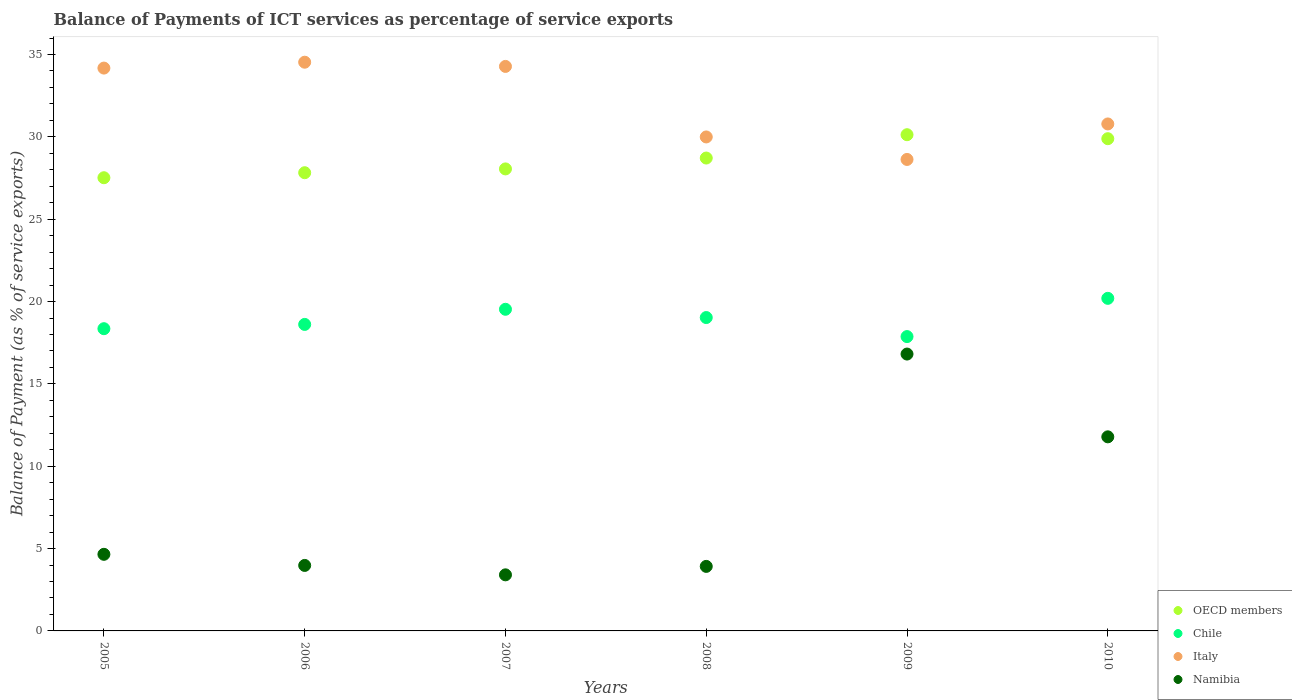How many different coloured dotlines are there?
Provide a succinct answer. 4. Is the number of dotlines equal to the number of legend labels?
Provide a short and direct response. Yes. What is the balance of payments of ICT services in Italy in 2010?
Your answer should be very brief. 30.78. Across all years, what is the maximum balance of payments of ICT services in OECD members?
Offer a terse response. 30.13. Across all years, what is the minimum balance of payments of ICT services in Namibia?
Ensure brevity in your answer.  3.41. What is the total balance of payments of ICT services in Namibia in the graph?
Keep it short and to the point. 44.55. What is the difference between the balance of payments of ICT services in Chile in 2006 and that in 2009?
Your answer should be compact. 0.74. What is the difference between the balance of payments of ICT services in OECD members in 2008 and the balance of payments of ICT services in Namibia in 2010?
Ensure brevity in your answer.  16.93. What is the average balance of payments of ICT services in Italy per year?
Ensure brevity in your answer.  32.06. In the year 2009, what is the difference between the balance of payments of ICT services in Italy and balance of payments of ICT services in Namibia?
Offer a very short reply. 11.82. What is the ratio of the balance of payments of ICT services in OECD members in 2008 to that in 2010?
Keep it short and to the point. 0.96. What is the difference between the highest and the second highest balance of payments of ICT services in Italy?
Provide a succinct answer. 0.26. What is the difference between the highest and the lowest balance of payments of ICT services in Italy?
Your response must be concise. 5.9. Is the sum of the balance of payments of ICT services in OECD members in 2007 and 2009 greater than the maximum balance of payments of ICT services in Italy across all years?
Ensure brevity in your answer.  Yes. Is it the case that in every year, the sum of the balance of payments of ICT services in Chile and balance of payments of ICT services in Italy  is greater than the sum of balance of payments of ICT services in Namibia and balance of payments of ICT services in OECD members?
Offer a very short reply. Yes. Is it the case that in every year, the sum of the balance of payments of ICT services in OECD members and balance of payments of ICT services in Italy  is greater than the balance of payments of ICT services in Namibia?
Offer a very short reply. Yes. Does the balance of payments of ICT services in Italy monotonically increase over the years?
Ensure brevity in your answer.  No. Is the balance of payments of ICT services in OECD members strictly greater than the balance of payments of ICT services in Chile over the years?
Your answer should be very brief. Yes. How many dotlines are there?
Keep it short and to the point. 4. How many years are there in the graph?
Ensure brevity in your answer.  6. Are the values on the major ticks of Y-axis written in scientific E-notation?
Provide a short and direct response. No. Does the graph contain grids?
Give a very brief answer. No. How many legend labels are there?
Give a very brief answer. 4. How are the legend labels stacked?
Your answer should be compact. Vertical. What is the title of the graph?
Ensure brevity in your answer.  Balance of Payments of ICT services as percentage of service exports. Does "Congo (Republic)" appear as one of the legend labels in the graph?
Provide a short and direct response. No. What is the label or title of the X-axis?
Your response must be concise. Years. What is the label or title of the Y-axis?
Provide a short and direct response. Balance of Payment (as % of service exports). What is the Balance of Payment (as % of service exports) in OECD members in 2005?
Provide a succinct answer. 27.52. What is the Balance of Payment (as % of service exports) in Chile in 2005?
Provide a succinct answer. 18.35. What is the Balance of Payment (as % of service exports) of Italy in 2005?
Provide a succinct answer. 34.17. What is the Balance of Payment (as % of service exports) of Namibia in 2005?
Make the answer very short. 4.65. What is the Balance of Payment (as % of service exports) of OECD members in 2006?
Give a very brief answer. 27.82. What is the Balance of Payment (as % of service exports) of Chile in 2006?
Your response must be concise. 18.61. What is the Balance of Payment (as % of service exports) in Italy in 2006?
Provide a short and direct response. 34.53. What is the Balance of Payment (as % of service exports) of Namibia in 2006?
Ensure brevity in your answer.  3.98. What is the Balance of Payment (as % of service exports) of OECD members in 2007?
Give a very brief answer. 28.05. What is the Balance of Payment (as % of service exports) of Chile in 2007?
Offer a terse response. 19.53. What is the Balance of Payment (as % of service exports) in Italy in 2007?
Keep it short and to the point. 34.28. What is the Balance of Payment (as % of service exports) of Namibia in 2007?
Ensure brevity in your answer.  3.41. What is the Balance of Payment (as % of service exports) in OECD members in 2008?
Give a very brief answer. 28.71. What is the Balance of Payment (as % of service exports) of Chile in 2008?
Offer a terse response. 19.03. What is the Balance of Payment (as % of service exports) in Italy in 2008?
Your response must be concise. 29.99. What is the Balance of Payment (as % of service exports) in Namibia in 2008?
Provide a short and direct response. 3.92. What is the Balance of Payment (as % of service exports) of OECD members in 2009?
Provide a short and direct response. 30.13. What is the Balance of Payment (as % of service exports) of Chile in 2009?
Your answer should be very brief. 17.87. What is the Balance of Payment (as % of service exports) of Italy in 2009?
Offer a very short reply. 28.63. What is the Balance of Payment (as % of service exports) in Namibia in 2009?
Provide a short and direct response. 16.81. What is the Balance of Payment (as % of service exports) of OECD members in 2010?
Provide a short and direct response. 29.89. What is the Balance of Payment (as % of service exports) in Chile in 2010?
Provide a succinct answer. 20.19. What is the Balance of Payment (as % of service exports) in Italy in 2010?
Offer a terse response. 30.78. What is the Balance of Payment (as % of service exports) of Namibia in 2010?
Your answer should be very brief. 11.78. Across all years, what is the maximum Balance of Payment (as % of service exports) of OECD members?
Make the answer very short. 30.13. Across all years, what is the maximum Balance of Payment (as % of service exports) of Chile?
Offer a very short reply. 20.19. Across all years, what is the maximum Balance of Payment (as % of service exports) in Italy?
Your response must be concise. 34.53. Across all years, what is the maximum Balance of Payment (as % of service exports) of Namibia?
Provide a succinct answer. 16.81. Across all years, what is the minimum Balance of Payment (as % of service exports) of OECD members?
Your response must be concise. 27.52. Across all years, what is the minimum Balance of Payment (as % of service exports) of Chile?
Offer a very short reply. 17.87. Across all years, what is the minimum Balance of Payment (as % of service exports) of Italy?
Your answer should be very brief. 28.63. Across all years, what is the minimum Balance of Payment (as % of service exports) in Namibia?
Keep it short and to the point. 3.41. What is the total Balance of Payment (as % of service exports) in OECD members in the graph?
Give a very brief answer. 172.12. What is the total Balance of Payment (as % of service exports) in Chile in the graph?
Offer a very short reply. 113.58. What is the total Balance of Payment (as % of service exports) in Italy in the graph?
Provide a succinct answer. 192.38. What is the total Balance of Payment (as % of service exports) in Namibia in the graph?
Your answer should be compact. 44.55. What is the difference between the Balance of Payment (as % of service exports) in OECD members in 2005 and that in 2006?
Provide a succinct answer. -0.3. What is the difference between the Balance of Payment (as % of service exports) of Chile in 2005 and that in 2006?
Offer a very short reply. -0.26. What is the difference between the Balance of Payment (as % of service exports) of Italy in 2005 and that in 2006?
Keep it short and to the point. -0.36. What is the difference between the Balance of Payment (as % of service exports) of Namibia in 2005 and that in 2006?
Make the answer very short. 0.67. What is the difference between the Balance of Payment (as % of service exports) in OECD members in 2005 and that in 2007?
Make the answer very short. -0.54. What is the difference between the Balance of Payment (as % of service exports) in Chile in 2005 and that in 2007?
Provide a short and direct response. -1.18. What is the difference between the Balance of Payment (as % of service exports) in Italy in 2005 and that in 2007?
Your answer should be compact. -0.1. What is the difference between the Balance of Payment (as % of service exports) in Namibia in 2005 and that in 2007?
Your answer should be compact. 1.25. What is the difference between the Balance of Payment (as % of service exports) of OECD members in 2005 and that in 2008?
Offer a very short reply. -1.2. What is the difference between the Balance of Payment (as % of service exports) of Chile in 2005 and that in 2008?
Provide a succinct answer. -0.68. What is the difference between the Balance of Payment (as % of service exports) of Italy in 2005 and that in 2008?
Your answer should be very brief. 4.18. What is the difference between the Balance of Payment (as % of service exports) of Namibia in 2005 and that in 2008?
Ensure brevity in your answer.  0.73. What is the difference between the Balance of Payment (as % of service exports) in OECD members in 2005 and that in 2009?
Offer a terse response. -2.61. What is the difference between the Balance of Payment (as % of service exports) in Chile in 2005 and that in 2009?
Make the answer very short. 0.48. What is the difference between the Balance of Payment (as % of service exports) of Italy in 2005 and that in 2009?
Offer a very short reply. 5.55. What is the difference between the Balance of Payment (as % of service exports) in Namibia in 2005 and that in 2009?
Provide a short and direct response. -12.16. What is the difference between the Balance of Payment (as % of service exports) of OECD members in 2005 and that in 2010?
Your answer should be very brief. -2.37. What is the difference between the Balance of Payment (as % of service exports) of Chile in 2005 and that in 2010?
Provide a succinct answer. -1.84. What is the difference between the Balance of Payment (as % of service exports) in Italy in 2005 and that in 2010?
Make the answer very short. 3.39. What is the difference between the Balance of Payment (as % of service exports) of Namibia in 2005 and that in 2010?
Make the answer very short. -7.13. What is the difference between the Balance of Payment (as % of service exports) in OECD members in 2006 and that in 2007?
Keep it short and to the point. -0.23. What is the difference between the Balance of Payment (as % of service exports) of Chile in 2006 and that in 2007?
Your response must be concise. -0.92. What is the difference between the Balance of Payment (as % of service exports) in Italy in 2006 and that in 2007?
Your answer should be compact. 0.26. What is the difference between the Balance of Payment (as % of service exports) of Namibia in 2006 and that in 2007?
Keep it short and to the point. 0.57. What is the difference between the Balance of Payment (as % of service exports) of OECD members in 2006 and that in 2008?
Give a very brief answer. -0.89. What is the difference between the Balance of Payment (as % of service exports) in Chile in 2006 and that in 2008?
Provide a short and direct response. -0.42. What is the difference between the Balance of Payment (as % of service exports) in Italy in 2006 and that in 2008?
Offer a very short reply. 4.54. What is the difference between the Balance of Payment (as % of service exports) in Namibia in 2006 and that in 2008?
Keep it short and to the point. 0.06. What is the difference between the Balance of Payment (as % of service exports) of OECD members in 2006 and that in 2009?
Provide a short and direct response. -2.31. What is the difference between the Balance of Payment (as % of service exports) of Chile in 2006 and that in 2009?
Provide a short and direct response. 0.74. What is the difference between the Balance of Payment (as % of service exports) of Italy in 2006 and that in 2009?
Provide a short and direct response. 5.9. What is the difference between the Balance of Payment (as % of service exports) in Namibia in 2006 and that in 2009?
Ensure brevity in your answer.  -12.83. What is the difference between the Balance of Payment (as % of service exports) in OECD members in 2006 and that in 2010?
Your response must be concise. -2.07. What is the difference between the Balance of Payment (as % of service exports) in Chile in 2006 and that in 2010?
Provide a short and direct response. -1.58. What is the difference between the Balance of Payment (as % of service exports) of Italy in 2006 and that in 2010?
Keep it short and to the point. 3.75. What is the difference between the Balance of Payment (as % of service exports) of Namibia in 2006 and that in 2010?
Offer a terse response. -7.81. What is the difference between the Balance of Payment (as % of service exports) of OECD members in 2007 and that in 2008?
Keep it short and to the point. -0.66. What is the difference between the Balance of Payment (as % of service exports) of Chile in 2007 and that in 2008?
Provide a succinct answer. 0.5. What is the difference between the Balance of Payment (as % of service exports) in Italy in 2007 and that in 2008?
Provide a succinct answer. 4.28. What is the difference between the Balance of Payment (as % of service exports) in Namibia in 2007 and that in 2008?
Keep it short and to the point. -0.51. What is the difference between the Balance of Payment (as % of service exports) in OECD members in 2007 and that in 2009?
Your response must be concise. -2.08. What is the difference between the Balance of Payment (as % of service exports) in Chile in 2007 and that in 2009?
Give a very brief answer. 1.66. What is the difference between the Balance of Payment (as % of service exports) in Italy in 2007 and that in 2009?
Your answer should be very brief. 5.65. What is the difference between the Balance of Payment (as % of service exports) of Namibia in 2007 and that in 2009?
Your response must be concise. -13.41. What is the difference between the Balance of Payment (as % of service exports) of OECD members in 2007 and that in 2010?
Make the answer very short. -1.83. What is the difference between the Balance of Payment (as % of service exports) in Chile in 2007 and that in 2010?
Provide a short and direct response. -0.66. What is the difference between the Balance of Payment (as % of service exports) in Italy in 2007 and that in 2010?
Give a very brief answer. 3.49. What is the difference between the Balance of Payment (as % of service exports) of Namibia in 2007 and that in 2010?
Your response must be concise. -8.38. What is the difference between the Balance of Payment (as % of service exports) in OECD members in 2008 and that in 2009?
Your answer should be compact. -1.42. What is the difference between the Balance of Payment (as % of service exports) in Chile in 2008 and that in 2009?
Your answer should be very brief. 1.16. What is the difference between the Balance of Payment (as % of service exports) in Italy in 2008 and that in 2009?
Offer a terse response. 1.37. What is the difference between the Balance of Payment (as % of service exports) in Namibia in 2008 and that in 2009?
Provide a succinct answer. -12.89. What is the difference between the Balance of Payment (as % of service exports) in OECD members in 2008 and that in 2010?
Provide a succinct answer. -1.17. What is the difference between the Balance of Payment (as % of service exports) of Chile in 2008 and that in 2010?
Provide a short and direct response. -1.17. What is the difference between the Balance of Payment (as % of service exports) in Italy in 2008 and that in 2010?
Offer a terse response. -0.79. What is the difference between the Balance of Payment (as % of service exports) of Namibia in 2008 and that in 2010?
Provide a short and direct response. -7.87. What is the difference between the Balance of Payment (as % of service exports) in OECD members in 2009 and that in 2010?
Offer a very short reply. 0.24. What is the difference between the Balance of Payment (as % of service exports) of Chile in 2009 and that in 2010?
Provide a succinct answer. -2.32. What is the difference between the Balance of Payment (as % of service exports) in Italy in 2009 and that in 2010?
Your response must be concise. -2.16. What is the difference between the Balance of Payment (as % of service exports) in Namibia in 2009 and that in 2010?
Offer a very short reply. 5.03. What is the difference between the Balance of Payment (as % of service exports) in OECD members in 2005 and the Balance of Payment (as % of service exports) in Chile in 2006?
Make the answer very short. 8.91. What is the difference between the Balance of Payment (as % of service exports) of OECD members in 2005 and the Balance of Payment (as % of service exports) of Italy in 2006?
Ensure brevity in your answer.  -7.01. What is the difference between the Balance of Payment (as % of service exports) in OECD members in 2005 and the Balance of Payment (as % of service exports) in Namibia in 2006?
Keep it short and to the point. 23.54. What is the difference between the Balance of Payment (as % of service exports) of Chile in 2005 and the Balance of Payment (as % of service exports) of Italy in 2006?
Make the answer very short. -16.18. What is the difference between the Balance of Payment (as % of service exports) of Chile in 2005 and the Balance of Payment (as % of service exports) of Namibia in 2006?
Make the answer very short. 14.37. What is the difference between the Balance of Payment (as % of service exports) in Italy in 2005 and the Balance of Payment (as % of service exports) in Namibia in 2006?
Offer a terse response. 30.2. What is the difference between the Balance of Payment (as % of service exports) in OECD members in 2005 and the Balance of Payment (as % of service exports) in Chile in 2007?
Your answer should be very brief. 7.99. What is the difference between the Balance of Payment (as % of service exports) in OECD members in 2005 and the Balance of Payment (as % of service exports) in Italy in 2007?
Your response must be concise. -6.76. What is the difference between the Balance of Payment (as % of service exports) in OECD members in 2005 and the Balance of Payment (as % of service exports) in Namibia in 2007?
Provide a succinct answer. 24.11. What is the difference between the Balance of Payment (as % of service exports) of Chile in 2005 and the Balance of Payment (as % of service exports) of Italy in 2007?
Your answer should be very brief. -15.92. What is the difference between the Balance of Payment (as % of service exports) of Chile in 2005 and the Balance of Payment (as % of service exports) of Namibia in 2007?
Keep it short and to the point. 14.95. What is the difference between the Balance of Payment (as % of service exports) of Italy in 2005 and the Balance of Payment (as % of service exports) of Namibia in 2007?
Make the answer very short. 30.77. What is the difference between the Balance of Payment (as % of service exports) of OECD members in 2005 and the Balance of Payment (as % of service exports) of Chile in 2008?
Give a very brief answer. 8.49. What is the difference between the Balance of Payment (as % of service exports) in OECD members in 2005 and the Balance of Payment (as % of service exports) in Italy in 2008?
Ensure brevity in your answer.  -2.48. What is the difference between the Balance of Payment (as % of service exports) in OECD members in 2005 and the Balance of Payment (as % of service exports) in Namibia in 2008?
Give a very brief answer. 23.6. What is the difference between the Balance of Payment (as % of service exports) of Chile in 2005 and the Balance of Payment (as % of service exports) of Italy in 2008?
Provide a succinct answer. -11.64. What is the difference between the Balance of Payment (as % of service exports) of Chile in 2005 and the Balance of Payment (as % of service exports) of Namibia in 2008?
Provide a succinct answer. 14.43. What is the difference between the Balance of Payment (as % of service exports) of Italy in 2005 and the Balance of Payment (as % of service exports) of Namibia in 2008?
Your answer should be compact. 30.26. What is the difference between the Balance of Payment (as % of service exports) of OECD members in 2005 and the Balance of Payment (as % of service exports) of Chile in 2009?
Give a very brief answer. 9.65. What is the difference between the Balance of Payment (as % of service exports) of OECD members in 2005 and the Balance of Payment (as % of service exports) of Italy in 2009?
Provide a short and direct response. -1.11. What is the difference between the Balance of Payment (as % of service exports) of OECD members in 2005 and the Balance of Payment (as % of service exports) of Namibia in 2009?
Your answer should be compact. 10.71. What is the difference between the Balance of Payment (as % of service exports) of Chile in 2005 and the Balance of Payment (as % of service exports) of Italy in 2009?
Offer a terse response. -10.28. What is the difference between the Balance of Payment (as % of service exports) of Chile in 2005 and the Balance of Payment (as % of service exports) of Namibia in 2009?
Give a very brief answer. 1.54. What is the difference between the Balance of Payment (as % of service exports) of Italy in 2005 and the Balance of Payment (as % of service exports) of Namibia in 2009?
Make the answer very short. 17.36. What is the difference between the Balance of Payment (as % of service exports) in OECD members in 2005 and the Balance of Payment (as % of service exports) in Chile in 2010?
Make the answer very short. 7.32. What is the difference between the Balance of Payment (as % of service exports) in OECD members in 2005 and the Balance of Payment (as % of service exports) in Italy in 2010?
Your answer should be compact. -3.27. What is the difference between the Balance of Payment (as % of service exports) of OECD members in 2005 and the Balance of Payment (as % of service exports) of Namibia in 2010?
Give a very brief answer. 15.73. What is the difference between the Balance of Payment (as % of service exports) in Chile in 2005 and the Balance of Payment (as % of service exports) in Italy in 2010?
Offer a very short reply. -12.43. What is the difference between the Balance of Payment (as % of service exports) in Chile in 2005 and the Balance of Payment (as % of service exports) in Namibia in 2010?
Ensure brevity in your answer.  6.57. What is the difference between the Balance of Payment (as % of service exports) of Italy in 2005 and the Balance of Payment (as % of service exports) of Namibia in 2010?
Provide a short and direct response. 22.39. What is the difference between the Balance of Payment (as % of service exports) in OECD members in 2006 and the Balance of Payment (as % of service exports) in Chile in 2007?
Give a very brief answer. 8.29. What is the difference between the Balance of Payment (as % of service exports) of OECD members in 2006 and the Balance of Payment (as % of service exports) of Italy in 2007?
Give a very brief answer. -6.45. What is the difference between the Balance of Payment (as % of service exports) in OECD members in 2006 and the Balance of Payment (as % of service exports) in Namibia in 2007?
Your answer should be compact. 24.42. What is the difference between the Balance of Payment (as % of service exports) of Chile in 2006 and the Balance of Payment (as % of service exports) of Italy in 2007?
Give a very brief answer. -15.66. What is the difference between the Balance of Payment (as % of service exports) of Chile in 2006 and the Balance of Payment (as % of service exports) of Namibia in 2007?
Your response must be concise. 15.21. What is the difference between the Balance of Payment (as % of service exports) of Italy in 2006 and the Balance of Payment (as % of service exports) of Namibia in 2007?
Provide a short and direct response. 31.13. What is the difference between the Balance of Payment (as % of service exports) of OECD members in 2006 and the Balance of Payment (as % of service exports) of Chile in 2008?
Your response must be concise. 8.79. What is the difference between the Balance of Payment (as % of service exports) in OECD members in 2006 and the Balance of Payment (as % of service exports) in Italy in 2008?
Offer a very short reply. -2.17. What is the difference between the Balance of Payment (as % of service exports) of OECD members in 2006 and the Balance of Payment (as % of service exports) of Namibia in 2008?
Provide a succinct answer. 23.9. What is the difference between the Balance of Payment (as % of service exports) of Chile in 2006 and the Balance of Payment (as % of service exports) of Italy in 2008?
Offer a terse response. -11.38. What is the difference between the Balance of Payment (as % of service exports) of Chile in 2006 and the Balance of Payment (as % of service exports) of Namibia in 2008?
Make the answer very short. 14.69. What is the difference between the Balance of Payment (as % of service exports) of Italy in 2006 and the Balance of Payment (as % of service exports) of Namibia in 2008?
Keep it short and to the point. 30.61. What is the difference between the Balance of Payment (as % of service exports) in OECD members in 2006 and the Balance of Payment (as % of service exports) in Chile in 2009?
Your response must be concise. 9.95. What is the difference between the Balance of Payment (as % of service exports) in OECD members in 2006 and the Balance of Payment (as % of service exports) in Italy in 2009?
Provide a succinct answer. -0.81. What is the difference between the Balance of Payment (as % of service exports) in OECD members in 2006 and the Balance of Payment (as % of service exports) in Namibia in 2009?
Provide a short and direct response. 11.01. What is the difference between the Balance of Payment (as % of service exports) in Chile in 2006 and the Balance of Payment (as % of service exports) in Italy in 2009?
Ensure brevity in your answer.  -10.02. What is the difference between the Balance of Payment (as % of service exports) of Chile in 2006 and the Balance of Payment (as % of service exports) of Namibia in 2009?
Keep it short and to the point. 1.8. What is the difference between the Balance of Payment (as % of service exports) in Italy in 2006 and the Balance of Payment (as % of service exports) in Namibia in 2009?
Your response must be concise. 17.72. What is the difference between the Balance of Payment (as % of service exports) in OECD members in 2006 and the Balance of Payment (as % of service exports) in Chile in 2010?
Keep it short and to the point. 7.63. What is the difference between the Balance of Payment (as % of service exports) of OECD members in 2006 and the Balance of Payment (as % of service exports) of Italy in 2010?
Provide a short and direct response. -2.96. What is the difference between the Balance of Payment (as % of service exports) of OECD members in 2006 and the Balance of Payment (as % of service exports) of Namibia in 2010?
Your answer should be compact. 16.04. What is the difference between the Balance of Payment (as % of service exports) of Chile in 2006 and the Balance of Payment (as % of service exports) of Italy in 2010?
Offer a very short reply. -12.17. What is the difference between the Balance of Payment (as % of service exports) of Chile in 2006 and the Balance of Payment (as % of service exports) of Namibia in 2010?
Provide a succinct answer. 6.83. What is the difference between the Balance of Payment (as % of service exports) in Italy in 2006 and the Balance of Payment (as % of service exports) in Namibia in 2010?
Your response must be concise. 22.75. What is the difference between the Balance of Payment (as % of service exports) in OECD members in 2007 and the Balance of Payment (as % of service exports) in Chile in 2008?
Offer a very short reply. 9.02. What is the difference between the Balance of Payment (as % of service exports) in OECD members in 2007 and the Balance of Payment (as % of service exports) in Italy in 2008?
Provide a succinct answer. -1.94. What is the difference between the Balance of Payment (as % of service exports) in OECD members in 2007 and the Balance of Payment (as % of service exports) in Namibia in 2008?
Your answer should be very brief. 24.13. What is the difference between the Balance of Payment (as % of service exports) in Chile in 2007 and the Balance of Payment (as % of service exports) in Italy in 2008?
Offer a terse response. -10.46. What is the difference between the Balance of Payment (as % of service exports) in Chile in 2007 and the Balance of Payment (as % of service exports) in Namibia in 2008?
Your answer should be very brief. 15.61. What is the difference between the Balance of Payment (as % of service exports) in Italy in 2007 and the Balance of Payment (as % of service exports) in Namibia in 2008?
Offer a terse response. 30.36. What is the difference between the Balance of Payment (as % of service exports) in OECD members in 2007 and the Balance of Payment (as % of service exports) in Chile in 2009?
Your answer should be very brief. 10.18. What is the difference between the Balance of Payment (as % of service exports) in OECD members in 2007 and the Balance of Payment (as % of service exports) in Italy in 2009?
Provide a short and direct response. -0.57. What is the difference between the Balance of Payment (as % of service exports) in OECD members in 2007 and the Balance of Payment (as % of service exports) in Namibia in 2009?
Make the answer very short. 11.24. What is the difference between the Balance of Payment (as % of service exports) of Chile in 2007 and the Balance of Payment (as % of service exports) of Italy in 2009?
Keep it short and to the point. -9.1. What is the difference between the Balance of Payment (as % of service exports) of Chile in 2007 and the Balance of Payment (as % of service exports) of Namibia in 2009?
Make the answer very short. 2.72. What is the difference between the Balance of Payment (as % of service exports) in Italy in 2007 and the Balance of Payment (as % of service exports) in Namibia in 2009?
Keep it short and to the point. 17.46. What is the difference between the Balance of Payment (as % of service exports) of OECD members in 2007 and the Balance of Payment (as % of service exports) of Chile in 2010?
Offer a very short reply. 7.86. What is the difference between the Balance of Payment (as % of service exports) of OECD members in 2007 and the Balance of Payment (as % of service exports) of Italy in 2010?
Keep it short and to the point. -2.73. What is the difference between the Balance of Payment (as % of service exports) in OECD members in 2007 and the Balance of Payment (as % of service exports) in Namibia in 2010?
Your answer should be very brief. 16.27. What is the difference between the Balance of Payment (as % of service exports) of Chile in 2007 and the Balance of Payment (as % of service exports) of Italy in 2010?
Offer a very short reply. -11.25. What is the difference between the Balance of Payment (as % of service exports) of Chile in 2007 and the Balance of Payment (as % of service exports) of Namibia in 2010?
Provide a succinct answer. 7.74. What is the difference between the Balance of Payment (as % of service exports) in Italy in 2007 and the Balance of Payment (as % of service exports) in Namibia in 2010?
Your answer should be very brief. 22.49. What is the difference between the Balance of Payment (as % of service exports) of OECD members in 2008 and the Balance of Payment (as % of service exports) of Chile in 2009?
Make the answer very short. 10.84. What is the difference between the Balance of Payment (as % of service exports) in OECD members in 2008 and the Balance of Payment (as % of service exports) in Italy in 2009?
Provide a short and direct response. 0.09. What is the difference between the Balance of Payment (as % of service exports) of OECD members in 2008 and the Balance of Payment (as % of service exports) of Namibia in 2009?
Ensure brevity in your answer.  11.9. What is the difference between the Balance of Payment (as % of service exports) of Chile in 2008 and the Balance of Payment (as % of service exports) of Italy in 2009?
Offer a terse response. -9.6. What is the difference between the Balance of Payment (as % of service exports) of Chile in 2008 and the Balance of Payment (as % of service exports) of Namibia in 2009?
Offer a terse response. 2.22. What is the difference between the Balance of Payment (as % of service exports) in Italy in 2008 and the Balance of Payment (as % of service exports) in Namibia in 2009?
Offer a very short reply. 13.18. What is the difference between the Balance of Payment (as % of service exports) in OECD members in 2008 and the Balance of Payment (as % of service exports) in Chile in 2010?
Your response must be concise. 8.52. What is the difference between the Balance of Payment (as % of service exports) of OECD members in 2008 and the Balance of Payment (as % of service exports) of Italy in 2010?
Offer a terse response. -2.07. What is the difference between the Balance of Payment (as % of service exports) in OECD members in 2008 and the Balance of Payment (as % of service exports) in Namibia in 2010?
Offer a very short reply. 16.93. What is the difference between the Balance of Payment (as % of service exports) of Chile in 2008 and the Balance of Payment (as % of service exports) of Italy in 2010?
Keep it short and to the point. -11.75. What is the difference between the Balance of Payment (as % of service exports) of Chile in 2008 and the Balance of Payment (as % of service exports) of Namibia in 2010?
Provide a short and direct response. 7.24. What is the difference between the Balance of Payment (as % of service exports) of Italy in 2008 and the Balance of Payment (as % of service exports) of Namibia in 2010?
Your response must be concise. 18.21. What is the difference between the Balance of Payment (as % of service exports) in OECD members in 2009 and the Balance of Payment (as % of service exports) in Chile in 2010?
Offer a very short reply. 9.94. What is the difference between the Balance of Payment (as % of service exports) in OECD members in 2009 and the Balance of Payment (as % of service exports) in Italy in 2010?
Provide a short and direct response. -0.65. What is the difference between the Balance of Payment (as % of service exports) of OECD members in 2009 and the Balance of Payment (as % of service exports) of Namibia in 2010?
Keep it short and to the point. 18.34. What is the difference between the Balance of Payment (as % of service exports) in Chile in 2009 and the Balance of Payment (as % of service exports) in Italy in 2010?
Keep it short and to the point. -12.91. What is the difference between the Balance of Payment (as % of service exports) of Chile in 2009 and the Balance of Payment (as % of service exports) of Namibia in 2010?
Your answer should be very brief. 6.09. What is the difference between the Balance of Payment (as % of service exports) of Italy in 2009 and the Balance of Payment (as % of service exports) of Namibia in 2010?
Your response must be concise. 16.84. What is the average Balance of Payment (as % of service exports) in OECD members per year?
Make the answer very short. 28.69. What is the average Balance of Payment (as % of service exports) in Chile per year?
Keep it short and to the point. 18.93. What is the average Balance of Payment (as % of service exports) in Italy per year?
Give a very brief answer. 32.06. What is the average Balance of Payment (as % of service exports) in Namibia per year?
Offer a terse response. 7.42. In the year 2005, what is the difference between the Balance of Payment (as % of service exports) in OECD members and Balance of Payment (as % of service exports) in Chile?
Your answer should be very brief. 9.17. In the year 2005, what is the difference between the Balance of Payment (as % of service exports) of OECD members and Balance of Payment (as % of service exports) of Italy?
Your answer should be compact. -6.66. In the year 2005, what is the difference between the Balance of Payment (as % of service exports) in OECD members and Balance of Payment (as % of service exports) in Namibia?
Offer a very short reply. 22.87. In the year 2005, what is the difference between the Balance of Payment (as % of service exports) in Chile and Balance of Payment (as % of service exports) in Italy?
Keep it short and to the point. -15.82. In the year 2005, what is the difference between the Balance of Payment (as % of service exports) of Chile and Balance of Payment (as % of service exports) of Namibia?
Make the answer very short. 13.7. In the year 2005, what is the difference between the Balance of Payment (as % of service exports) in Italy and Balance of Payment (as % of service exports) in Namibia?
Provide a succinct answer. 29.52. In the year 2006, what is the difference between the Balance of Payment (as % of service exports) in OECD members and Balance of Payment (as % of service exports) in Chile?
Provide a short and direct response. 9.21. In the year 2006, what is the difference between the Balance of Payment (as % of service exports) in OECD members and Balance of Payment (as % of service exports) in Italy?
Offer a very short reply. -6.71. In the year 2006, what is the difference between the Balance of Payment (as % of service exports) of OECD members and Balance of Payment (as % of service exports) of Namibia?
Offer a terse response. 23.85. In the year 2006, what is the difference between the Balance of Payment (as % of service exports) of Chile and Balance of Payment (as % of service exports) of Italy?
Keep it short and to the point. -15.92. In the year 2006, what is the difference between the Balance of Payment (as % of service exports) of Chile and Balance of Payment (as % of service exports) of Namibia?
Make the answer very short. 14.63. In the year 2006, what is the difference between the Balance of Payment (as % of service exports) of Italy and Balance of Payment (as % of service exports) of Namibia?
Your answer should be compact. 30.55. In the year 2007, what is the difference between the Balance of Payment (as % of service exports) in OECD members and Balance of Payment (as % of service exports) in Chile?
Ensure brevity in your answer.  8.52. In the year 2007, what is the difference between the Balance of Payment (as % of service exports) of OECD members and Balance of Payment (as % of service exports) of Italy?
Offer a terse response. -6.22. In the year 2007, what is the difference between the Balance of Payment (as % of service exports) in OECD members and Balance of Payment (as % of service exports) in Namibia?
Provide a short and direct response. 24.65. In the year 2007, what is the difference between the Balance of Payment (as % of service exports) of Chile and Balance of Payment (as % of service exports) of Italy?
Make the answer very short. -14.75. In the year 2007, what is the difference between the Balance of Payment (as % of service exports) of Chile and Balance of Payment (as % of service exports) of Namibia?
Keep it short and to the point. 16.12. In the year 2007, what is the difference between the Balance of Payment (as % of service exports) of Italy and Balance of Payment (as % of service exports) of Namibia?
Your answer should be very brief. 30.87. In the year 2008, what is the difference between the Balance of Payment (as % of service exports) of OECD members and Balance of Payment (as % of service exports) of Chile?
Ensure brevity in your answer.  9.69. In the year 2008, what is the difference between the Balance of Payment (as % of service exports) of OECD members and Balance of Payment (as % of service exports) of Italy?
Keep it short and to the point. -1.28. In the year 2008, what is the difference between the Balance of Payment (as % of service exports) of OECD members and Balance of Payment (as % of service exports) of Namibia?
Make the answer very short. 24.79. In the year 2008, what is the difference between the Balance of Payment (as % of service exports) in Chile and Balance of Payment (as % of service exports) in Italy?
Offer a terse response. -10.97. In the year 2008, what is the difference between the Balance of Payment (as % of service exports) of Chile and Balance of Payment (as % of service exports) of Namibia?
Your answer should be very brief. 15.11. In the year 2008, what is the difference between the Balance of Payment (as % of service exports) in Italy and Balance of Payment (as % of service exports) in Namibia?
Offer a very short reply. 26.08. In the year 2009, what is the difference between the Balance of Payment (as % of service exports) in OECD members and Balance of Payment (as % of service exports) in Chile?
Make the answer very short. 12.26. In the year 2009, what is the difference between the Balance of Payment (as % of service exports) in OECD members and Balance of Payment (as % of service exports) in Italy?
Provide a succinct answer. 1.5. In the year 2009, what is the difference between the Balance of Payment (as % of service exports) in OECD members and Balance of Payment (as % of service exports) in Namibia?
Your response must be concise. 13.32. In the year 2009, what is the difference between the Balance of Payment (as % of service exports) of Chile and Balance of Payment (as % of service exports) of Italy?
Offer a very short reply. -10.76. In the year 2009, what is the difference between the Balance of Payment (as % of service exports) in Chile and Balance of Payment (as % of service exports) in Namibia?
Ensure brevity in your answer.  1.06. In the year 2009, what is the difference between the Balance of Payment (as % of service exports) of Italy and Balance of Payment (as % of service exports) of Namibia?
Your answer should be very brief. 11.82. In the year 2010, what is the difference between the Balance of Payment (as % of service exports) of OECD members and Balance of Payment (as % of service exports) of Chile?
Ensure brevity in your answer.  9.69. In the year 2010, what is the difference between the Balance of Payment (as % of service exports) in OECD members and Balance of Payment (as % of service exports) in Italy?
Offer a very short reply. -0.9. In the year 2010, what is the difference between the Balance of Payment (as % of service exports) in OECD members and Balance of Payment (as % of service exports) in Namibia?
Give a very brief answer. 18.1. In the year 2010, what is the difference between the Balance of Payment (as % of service exports) in Chile and Balance of Payment (as % of service exports) in Italy?
Ensure brevity in your answer.  -10.59. In the year 2010, what is the difference between the Balance of Payment (as % of service exports) of Chile and Balance of Payment (as % of service exports) of Namibia?
Ensure brevity in your answer.  8.41. In the year 2010, what is the difference between the Balance of Payment (as % of service exports) of Italy and Balance of Payment (as % of service exports) of Namibia?
Offer a very short reply. 19. What is the ratio of the Balance of Payment (as % of service exports) of OECD members in 2005 to that in 2006?
Offer a very short reply. 0.99. What is the ratio of the Balance of Payment (as % of service exports) of Chile in 2005 to that in 2006?
Ensure brevity in your answer.  0.99. What is the ratio of the Balance of Payment (as % of service exports) of Italy in 2005 to that in 2006?
Offer a very short reply. 0.99. What is the ratio of the Balance of Payment (as % of service exports) in Namibia in 2005 to that in 2006?
Your answer should be compact. 1.17. What is the ratio of the Balance of Payment (as % of service exports) in OECD members in 2005 to that in 2007?
Make the answer very short. 0.98. What is the ratio of the Balance of Payment (as % of service exports) of Chile in 2005 to that in 2007?
Your answer should be very brief. 0.94. What is the ratio of the Balance of Payment (as % of service exports) in Namibia in 2005 to that in 2007?
Ensure brevity in your answer.  1.37. What is the ratio of the Balance of Payment (as % of service exports) of OECD members in 2005 to that in 2008?
Your response must be concise. 0.96. What is the ratio of the Balance of Payment (as % of service exports) in Chile in 2005 to that in 2008?
Make the answer very short. 0.96. What is the ratio of the Balance of Payment (as % of service exports) in Italy in 2005 to that in 2008?
Ensure brevity in your answer.  1.14. What is the ratio of the Balance of Payment (as % of service exports) in Namibia in 2005 to that in 2008?
Your response must be concise. 1.19. What is the ratio of the Balance of Payment (as % of service exports) of OECD members in 2005 to that in 2009?
Ensure brevity in your answer.  0.91. What is the ratio of the Balance of Payment (as % of service exports) of Chile in 2005 to that in 2009?
Keep it short and to the point. 1.03. What is the ratio of the Balance of Payment (as % of service exports) in Italy in 2005 to that in 2009?
Your response must be concise. 1.19. What is the ratio of the Balance of Payment (as % of service exports) of Namibia in 2005 to that in 2009?
Keep it short and to the point. 0.28. What is the ratio of the Balance of Payment (as % of service exports) in OECD members in 2005 to that in 2010?
Ensure brevity in your answer.  0.92. What is the ratio of the Balance of Payment (as % of service exports) of Chile in 2005 to that in 2010?
Give a very brief answer. 0.91. What is the ratio of the Balance of Payment (as % of service exports) of Italy in 2005 to that in 2010?
Give a very brief answer. 1.11. What is the ratio of the Balance of Payment (as % of service exports) of Namibia in 2005 to that in 2010?
Provide a succinct answer. 0.39. What is the ratio of the Balance of Payment (as % of service exports) in Chile in 2006 to that in 2007?
Provide a succinct answer. 0.95. What is the ratio of the Balance of Payment (as % of service exports) of Italy in 2006 to that in 2007?
Your answer should be compact. 1.01. What is the ratio of the Balance of Payment (as % of service exports) in Namibia in 2006 to that in 2007?
Offer a terse response. 1.17. What is the ratio of the Balance of Payment (as % of service exports) in Chile in 2006 to that in 2008?
Provide a short and direct response. 0.98. What is the ratio of the Balance of Payment (as % of service exports) of Italy in 2006 to that in 2008?
Your answer should be compact. 1.15. What is the ratio of the Balance of Payment (as % of service exports) of Namibia in 2006 to that in 2008?
Offer a very short reply. 1.01. What is the ratio of the Balance of Payment (as % of service exports) in OECD members in 2006 to that in 2009?
Ensure brevity in your answer.  0.92. What is the ratio of the Balance of Payment (as % of service exports) of Chile in 2006 to that in 2009?
Give a very brief answer. 1.04. What is the ratio of the Balance of Payment (as % of service exports) of Italy in 2006 to that in 2009?
Offer a terse response. 1.21. What is the ratio of the Balance of Payment (as % of service exports) in Namibia in 2006 to that in 2009?
Your answer should be compact. 0.24. What is the ratio of the Balance of Payment (as % of service exports) in OECD members in 2006 to that in 2010?
Provide a short and direct response. 0.93. What is the ratio of the Balance of Payment (as % of service exports) of Chile in 2006 to that in 2010?
Offer a terse response. 0.92. What is the ratio of the Balance of Payment (as % of service exports) in Italy in 2006 to that in 2010?
Your response must be concise. 1.12. What is the ratio of the Balance of Payment (as % of service exports) of Namibia in 2006 to that in 2010?
Your response must be concise. 0.34. What is the ratio of the Balance of Payment (as % of service exports) in OECD members in 2007 to that in 2008?
Offer a terse response. 0.98. What is the ratio of the Balance of Payment (as % of service exports) in Chile in 2007 to that in 2008?
Make the answer very short. 1.03. What is the ratio of the Balance of Payment (as % of service exports) in Italy in 2007 to that in 2008?
Provide a succinct answer. 1.14. What is the ratio of the Balance of Payment (as % of service exports) in Namibia in 2007 to that in 2008?
Keep it short and to the point. 0.87. What is the ratio of the Balance of Payment (as % of service exports) in OECD members in 2007 to that in 2009?
Provide a short and direct response. 0.93. What is the ratio of the Balance of Payment (as % of service exports) of Chile in 2007 to that in 2009?
Offer a very short reply. 1.09. What is the ratio of the Balance of Payment (as % of service exports) in Italy in 2007 to that in 2009?
Your answer should be compact. 1.2. What is the ratio of the Balance of Payment (as % of service exports) in Namibia in 2007 to that in 2009?
Your answer should be compact. 0.2. What is the ratio of the Balance of Payment (as % of service exports) of OECD members in 2007 to that in 2010?
Provide a succinct answer. 0.94. What is the ratio of the Balance of Payment (as % of service exports) in Chile in 2007 to that in 2010?
Ensure brevity in your answer.  0.97. What is the ratio of the Balance of Payment (as % of service exports) of Italy in 2007 to that in 2010?
Your answer should be compact. 1.11. What is the ratio of the Balance of Payment (as % of service exports) in Namibia in 2007 to that in 2010?
Keep it short and to the point. 0.29. What is the ratio of the Balance of Payment (as % of service exports) of OECD members in 2008 to that in 2009?
Your answer should be very brief. 0.95. What is the ratio of the Balance of Payment (as % of service exports) of Chile in 2008 to that in 2009?
Offer a terse response. 1.06. What is the ratio of the Balance of Payment (as % of service exports) in Italy in 2008 to that in 2009?
Ensure brevity in your answer.  1.05. What is the ratio of the Balance of Payment (as % of service exports) of Namibia in 2008 to that in 2009?
Offer a terse response. 0.23. What is the ratio of the Balance of Payment (as % of service exports) of OECD members in 2008 to that in 2010?
Make the answer very short. 0.96. What is the ratio of the Balance of Payment (as % of service exports) of Chile in 2008 to that in 2010?
Your answer should be very brief. 0.94. What is the ratio of the Balance of Payment (as % of service exports) of Italy in 2008 to that in 2010?
Your response must be concise. 0.97. What is the ratio of the Balance of Payment (as % of service exports) in Namibia in 2008 to that in 2010?
Make the answer very short. 0.33. What is the ratio of the Balance of Payment (as % of service exports) of Chile in 2009 to that in 2010?
Provide a short and direct response. 0.89. What is the ratio of the Balance of Payment (as % of service exports) in Italy in 2009 to that in 2010?
Ensure brevity in your answer.  0.93. What is the ratio of the Balance of Payment (as % of service exports) of Namibia in 2009 to that in 2010?
Your response must be concise. 1.43. What is the difference between the highest and the second highest Balance of Payment (as % of service exports) of OECD members?
Offer a very short reply. 0.24. What is the difference between the highest and the second highest Balance of Payment (as % of service exports) of Chile?
Give a very brief answer. 0.66. What is the difference between the highest and the second highest Balance of Payment (as % of service exports) of Italy?
Ensure brevity in your answer.  0.26. What is the difference between the highest and the second highest Balance of Payment (as % of service exports) in Namibia?
Make the answer very short. 5.03. What is the difference between the highest and the lowest Balance of Payment (as % of service exports) in OECD members?
Provide a short and direct response. 2.61. What is the difference between the highest and the lowest Balance of Payment (as % of service exports) of Chile?
Offer a very short reply. 2.32. What is the difference between the highest and the lowest Balance of Payment (as % of service exports) in Italy?
Your answer should be very brief. 5.9. What is the difference between the highest and the lowest Balance of Payment (as % of service exports) in Namibia?
Provide a succinct answer. 13.41. 